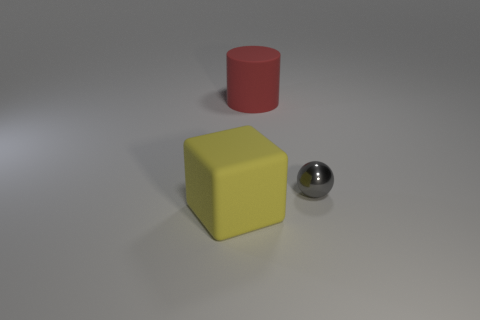Are there any other things that are the same material as the small sphere?
Your response must be concise. No. Is there anything else that is the same size as the shiny thing?
Provide a short and direct response. No. What size is the yellow thing in front of the tiny metallic object?
Provide a succinct answer. Large. Is the number of gray metallic balls less than the number of big yellow matte spheres?
Keep it short and to the point. No. Does the big thing behind the small gray object have the same material as the large yellow object left of the tiny gray object?
Offer a very short reply. Yes. What shape is the matte object that is in front of the small ball on the right side of the big red cylinder behind the sphere?
Keep it short and to the point. Cube. What number of tiny balls are the same material as the big red object?
Keep it short and to the point. 0. How many big matte blocks are in front of the matte thing to the right of the large yellow matte object?
Provide a short and direct response. 1. The thing that is left of the small sphere and in front of the red object has what shape?
Offer a very short reply. Cube. There is a object that is the same size as the red matte cylinder; what is its shape?
Offer a very short reply. Cube. 